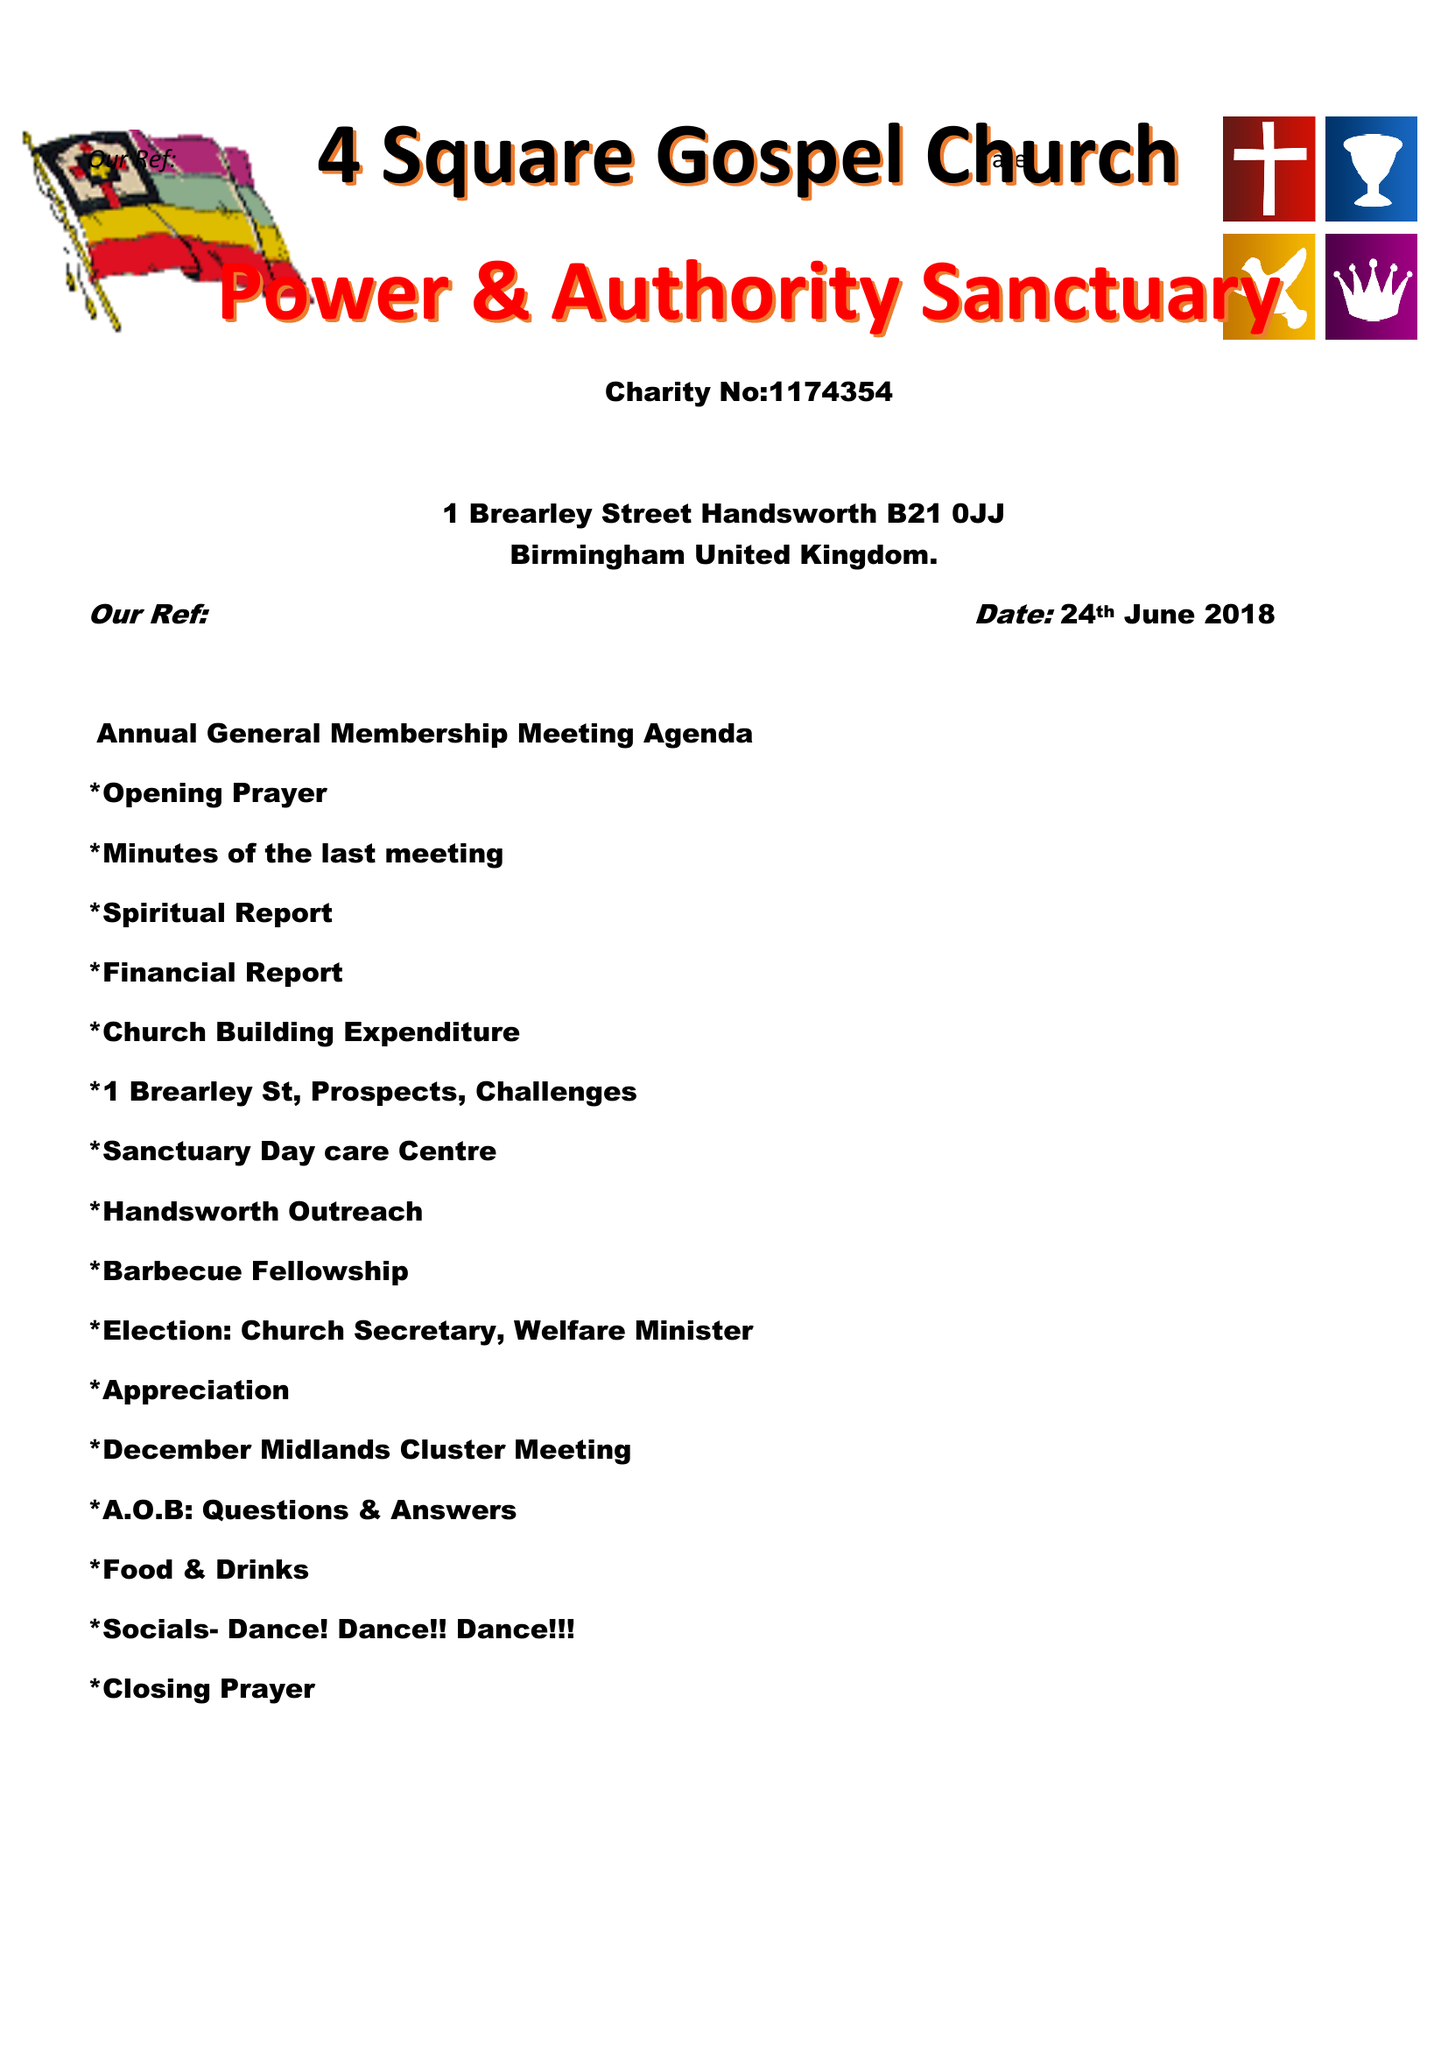What is the value for the address__street_line?
Answer the question using a single word or phrase. 45 WASDALE ROAD 